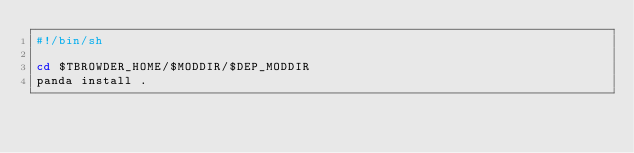<code> <loc_0><loc_0><loc_500><loc_500><_Bash_>#!/bin/sh

cd $TBROWDER_HOME/$MODDIR/$DEP_MODDIR
panda install .
</code> 